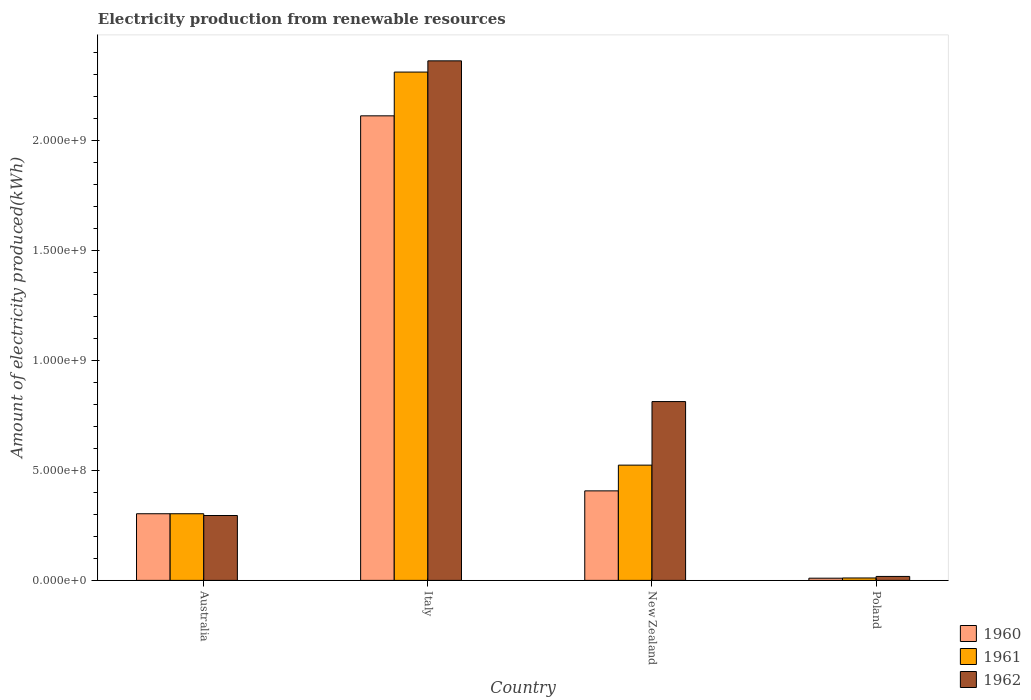How many different coloured bars are there?
Offer a very short reply. 3. What is the amount of electricity produced in 1962 in Australia?
Keep it short and to the point. 2.95e+08. Across all countries, what is the maximum amount of electricity produced in 1961?
Ensure brevity in your answer.  2.31e+09. Across all countries, what is the minimum amount of electricity produced in 1961?
Keep it short and to the point. 1.10e+07. In which country was the amount of electricity produced in 1960 minimum?
Ensure brevity in your answer.  Poland. What is the total amount of electricity produced in 1961 in the graph?
Give a very brief answer. 3.15e+09. What is the difference between the amount of electricity produced in 1962 in Italy and that in New Zealand?
Give a very brief answer. 1.55e+09. What is the difference between the amount of electricity produced in 1961 in Italy and the amount of electricity produced in 1960 in Australia?
Ensure brevity in your answer.  2.01e+09. What is the average amount of electricity produced in 1960 per country?
Provide a short and direct response. 7.08e+08. What is the difference between the amount of electricity produced of/in 1962 and amount of electricity produced of/in 1961 in New Zealand?
Ensure brevity in your answer.  2.89e+08. In how many countries, is the amount of electricity produced in 1961 greater than 500000000 kWh?
Offer a terse response. 2. What is the ratio of the amount of electricity produced in 1961 in Australia to that in Poland?
Provide a short and direct response. 27.55. Is the difference between the amount of electricity produced in 1962 in Australia and Poland greater than the difference between the amount of electricity produced in 1961 in Australia and Poland?
Offer a terse response. No. What is the difference between the highest and the second highest amount of electricity produced in 1961?
Make the answer very short. 1.79e+09. What is the difference between the highest and the lowest amount of electricity produced in 1960?
Your answer should be very brief. 2.10e+09. What does the 1st bar from the left in Poland represents?
Offer a very short reply. 1960. What does the 3rd bar from the right in New Zealand represents?
Keep it short and to the point. 1960. Is it the case that in every country, the sum of the amount of electricity produced in 1961 and amount of electricity produced in 1960 is greater than the amount of electricity produced in 1962?
Your response must be concise. Yes. Are all the bars in the graph horizontal?
Offer a terse response. No. What is the difference between two consecutive major ticks on the Y-axis?
Offer a terse response. 5.00e+08. Does the graph contain any zero values?
Give a very brief answer. No. Does the graph contain grids?
Provide a succinct answer. No. How many legend labels are there?
Provide a short and direct response. 3. What is the title of the graph?
Make the answer very short. Electricity production from renewable resources. What is the label or title of the Y-axis?
Keep it short and to the point. Amount of electricity produced(kWh). What is the Amount of electricity produced(kWh) of 1960 in Australia?
Your answer should be compact. 3.03e+08. What is the Amount of electricity produced(kWh) of 1961 in Australia?
Provide a succinct answer. 3.03e+08. What is the Amount of electricity produced(kWh) of 1962 in Australia?
Your response must be concise. 2.95e+08. What is the Amount of electricity produced(kWh) in 1960 in Italy?
Offer a very short reply. 2.11e+09. What is the Amount of electricity produced(kWh) in 1961 in Italy?
Your answer should be very brief. 2.31e+09. What is the Amount of electricity produced(kWh) in 1962 in Italy?
Keep it short and to the point. 2.36e+09. What is the Amount of electricity produced(kWh) of 1960 in New Zealand?
Offer a very short reply. 4.07e+08. What is the Amount of electricity produced(kWh) of 1961 in New Zealand?
Provide a succinct answer. 5.24e+08. What is the Amount of electricity produced(kWh) in 1962 in New Zealand?
Provide a succinct answer. 8.13e+08. What is the Amount of electricity produced(kWh) of 1961 in Poland?
Provide a succinct answer. 1.10e+07. What is the Amount of electricity produced(kWh) in 1962 in Poland?
Give a very brief answer. 1.80e+07. Across all countries, what is the maximum Amount of electricity produced(kWh) of 1960?
Give a very brief answer. 2.11e+09. Across all countries, what is the maximum Amount of electricity produced(kWh) in 1961?
Give a very brief answer. 2.31e+09. Across all countries, what is the maximum Amount of electricity produced(kWh) of 1962?
Make the answer very short. 2.36e+09. Across all countries, what is the minimum Amount of electricity produced(kWh) of 1961?
Keep it short and to the point. 1.10e+07. Across all countries, what is the minimum Amount of electricity produced(kWh) of 1962?
Make the answer very short. 1.80e+07. What is the total Amount of electricity produced(kWh) of 1960 in the graph?
Your answer should be very brief. 2.83e+09. What is the total Amount of electricity produced(kWh) of 1961 in the graph?
Ensure brevity in your answer.  3.15e+09. What is the total Amount of electricity produced(kWh) in 1962 in the graph?
Your answer should be very brief. 3.49e+09. What is the difference between the Amount of electricity produced(kWh) of 1960 in Australia and that in Italy?
Keep it short and to the point. -1.81e+09. What is the difference between the Amount of electricity produced(kWh) in 1961 in Australia and that in Italy?
Keep it short and to the point. -2.01e+09. What is the difference between the Amount of electricity produced(kWh) in 1962 in Australia and that in Italy?
Your answer should be compact. -2.07e+09. What is the difference between the Amount of electricity produced(kWh) of 1960 in Australia and that in New Zealand?
Offer a terse response. -1.04e+08. What is the difference between the Amount of electricity produced(kWh) in 1961 in Australia and that in New Zealand?
Provide a succinct answer. -2.21e+08. What is the difference between the Amount of electricity produced(kWh) of 1962 in Australia and that in New Zealand?
Provide a short and direct response. -5.18e+08. What is the difference between the Amount of electricity produced(kWh) in 1960 in Australia and that in Poland?
Provide a succinct answer. 2.93e+08. What is the difference between the Amount of electricity produced(kWh) of 1961 in Australia and that in Poland?
Keep it short and to the point. 2.92e+08. What is the difference between the Amount of electricity produced(kWh) in 1962 in Australia and that in Poland?
Give a very brief answer. 2.77e+08. What is the difference between the Amount of electricity produced(kWh) of 1960 in Italy and that in New Zealand?
Your answer should be compact. 1.70e+09. What is the difference between the Amount of electricity produced(kWh) of 1961 in Italy and that in New Zealand?
Keep it short and to the point. 1.79e+09. What is the difference between the Amount of electricity produced(kWh) of 1962 in Italy and that in New Zealand?
Provide a succinct answer. 1.55e+09. What is the difference between the Amount of electricity produced(kWh) of 1960 in Italy and that in Poland?
Provide a succinct answer. 2.10e+09. What is the difference between the Amount of electricity produced(kWh) in 1961 in Italy and that in Poland?
Ensure brevity in your answer.  2.30e+09. What is the difference between the Amount of electricity produced(kWh) in 1962 in Italy and that in Poland?
Keep it short and to the point. 2.34e+09. What is the difference between the Amount of electricity produced(kWh) of 1960 in New Zealand and that in Poland?
Make the answer very short. 3.97e+08. What is the difference between the Amount of electricity produced(kWh) in 1961 in New Zealand and that in Poland?
Ensure brevity in your answer.  5.13e+08. What is the difference between the Amount of electricity produced(kWh) in 1962 in New Zealand and that in Poland?
Give a very brief answer. 7.95e+08. What is the difference between the Amount of electricity produced(kWh) in 1960 in Australia and the Amount of electricity produced(kWh) in 1961 in Italy?
Your answer should be very brief. -2.01e+09. What is the difference between the Amount of electricity produced(kWh) in 1960 in Australia and the Amount of electricity produced(kWh) in 1962 in Italy?
Give a very brief answer. -2.06e+09. What is the difference between the Amount of electricity produced(kWh) of 1961 in Australia and the Amount of electricity produced(kWh) of 1962 in Italy?
Your answer should be compact. -2.06e+09. What is the difference between the Amount of electricity produced(kWh) in 1960 in Australia and the Amount of electricity produced(kWh) in 1961 in New Zealand?
Provide a short and direct response. -2.21e+08. What is the difference between the Amount of electricity produced(kWh) in 1960 in Australia and the Amount of electricity produced(kWh) in 1962 in New Zealand?
Your answer should be compact. -5.10e+08. What is the difference between the Amount of electricity produced(kWh) of 1961 in Australia and the Amount of electricity produced(kWh) of 1962 in New Zealand?
Ensure brevity in your answer.  -5.10e+08. What is the difference between the Amount of electricity produced(kWh) in 1960 in Australia and the Amount of electricity produced(kWh) in 1961 in Poland?
Offer a very short reply. 2.92e+08. What is the difference between the Amount of electricity produced(kWh) of 1960 in Australia and the Amount of electricity produced(kWh) of 1962 in Poland?
Your answer should be compact. 2.85e+08. What is the difference between the Amount of electricity produced(kWh) in 1961 in Australia and the Amount of electricity produced(kWh) in 1962 in Poland?
Offer a terse response. 2.85e+08. What is the difference between the Amount of electricity produced(kWh) in 1960 in Italy and the Amount of electricity produced(kWh) in 1961 in New Zealand?
Make the answer very short. 1.59e+09. What is the difference between the Amount of electricity produced(kWh) in 1960 in Italy and the Amount of electricity produced(kWh) in 1962 in New Zealand?
Offer a very short reply. 1.30e+09. What is the difference between the Amount of electricity produced(kWh) of 1961 in Italy and the Amount of electricity produced(kWh) of 1962 in New Zealand?
Provide a short and direct response. 1.50e+09. What is the difference between the Amount of electricity produced(kWh) in 1960 in Italy and the Amount of electricity produced(kWh) in 1961 in Poland?
Give a very brief answer. 2.10e+09. What is the difference between the Amount of electricity produced(kWh) of 1960 in Italy and the Amount of electricity produced(kWh) of 1962 in Poland?
Your response must be concise. 2.09e+09. What is the difference between the Amount of electricity produced(kWh) of 1961 in Italy and the Amount of electricity produced(kWh) of 1962 in Poland?
Give a very brief answer. 2.29e+09. What is the difference between the Amount of electricity produced(kWh) in 1960 in New Zealand and the Amount of electricity produced(kWh) in 1961 in Poland?
Your answer should be compact. 3.96e+08. What is the difference between the Amount of electricity produced(kWh) in 1960 in New Zealand and the Amount of electricity produced(kWh) in 1962 in Poland?
Make the answer very short. 3.89e+08. What is the difference between the Amount of electricity produced(kWh) of 1961 in New Zealand and the Amount of electricity produced(kWh) of 1962 in Poland?
Your answer should be compact. 5.06e+08. What is the average Amount of electricity produced(kWh) in 1960 per country?
Provide a succinct answer. 7.08e+08. What is the average Amount of electricity produced(kWh) of 1961 per country?
Make the answer very short. 7.87e+08. What is the average Amount of electricity produced(kWh) in 1962 per country?
Make the answer very short. 8.72e+08. What is the difference between the Amount of electricity produced(kWh) of 1960 and Amount of electricity produced(kWh) of 1961 in Australia?
Offer a terse response. 0. What is the difference between the Amount of electricity produced(kWh) of 1960 and Amount of electricity produced(kWh) of 1962 in Australia?
Your answer should be very brief. 8.00e+06. What is the difference between the Amount of electricity produced(kWh) of 1960 and Amount of electricity produced(kWh) of 1961 in Italy?
Offer a very short reply. -1.99e+08. What is the difference between the Amount of electricity produced(kWh) in 1960 and Amount of electricity produced(kWh) in 1962 in Italy?
Provide a succinct answer. -2.50e+08. What is the difference between the Amount of electricity produced(kWh) in 1961 and Amount of electricity produced(kWh) in 1962 in Italy?
Your response must be concise. -5.10e+07. What is the difference between the Amount of electricity produced(kWh) in 1960 and Amount of electricity produced(kWh) in 1961 in New Zealand?
Give a very brief answer. -1.17e+08. What is the difference between the Amount of electricity produced(kWh) in 1960 and Amount of electricity produced(kWh) in 1962 in New Zealand?
Your response must be concise. -4.06e+08. What is the difference between the Amount of electricity produced(kWh) of 1961 and Amount of electricity produced(kWh) of 1962 in New Zealand?
Give a very brief answer. -2.89e+08. What is the difference between the Amount of electricity produced(kWh) in 1960 and Amount of electricity produced(kWh) in 1961 in Poland?
Ensure brevity in your answer.  -1.00e+06. What is the difference between the Amount of electricity produced(kWh) of 1960 and Amount of electricity produced(kWh) of 1962 in Poland?
Your answer should be compact. -8.00e+06. What is the difference between the Amount of electricity produced(kWh) in 1961 and Amount of electricity produced(kWh) in 1962 in Poland?
Make the answer very short. -7.00e+06. What is the ratio of the Amount of electricity produced(kWh) in 1960 in Australia to that in Italy?
Make the answer very short. 0.14. What is the ratio of the Amount of electricity produced(kWh) in 1961 in Australia to that in Italy?
Your answer should be very brief. 0.13. What is the ratio of the Amount of electricity produced(kWh) in 1962 in Australia to that in Italy?
Your answer should be compact. 0.12. What is the ratio of the Amount of electricity produced(kWh) in 1960 in Australia to that in New Zealand?
Keep it short and to the point. 0.74. What is the ratio of the Amount of electricity produced(kWh) in 1961 in Australia to that in New Zealand?
Make the answer very short. 0.58. What is the ratio of the Amount of electricity produced(kWh) in 1962 in Australia to that in New Zealand?
Your response must be concise. 0.36. What is the ratio of the Amount of electricity produced(kWh) of 1960 in Australia to that in Poland?
Ensure brevity in your answer.  30.3. What is the ratio of the Amount of electricity produced(kWh) of 1961 in Australia to that in Poland?
Make the answer very short. 27.55. What is the ratio of the Amount of electricity produced(kWh) of 1962 in Australia to that in Poland?
Your answer should be compact. 16.39. What is the ratio of the Amount of electricity produced(kWh) of 1960 in Italy to that in New Zealand?
Offer a very short reply. 5.19. What is the ratio of the Amount of electricity produced(kWh) in 1961 in Italy to that in New Zealand?
Offer a very short reply. 4.41. What is the ratio of the Amount of electricity produced(kWh) in 1962 in Italy to that in New Zealand?
Offer a very short reply. 2.91. What is the ratio of the Amount of electricity produced(kWh) in 1960 in Italy to that in Poland?
Your answer should be very brief. 211.2. What is the ratio of the Amount of electricity produced(kWh) of 1961 in Italy to that in Poland?
Give a very brief answer. 210.09. What is the ratio of the Amount of electricity produced(kWh) in 1962 in Italy to that in Poland?
Ensure brevity in your answer.  131.22. What is the ratio of the Amount of electricity produced(kWh) of 1960 in New Zealand to that in Poland?
Your answer should be very brief. 40.7. What is the ratio of the Amount of electricity produced(kWh) in 1961 in New Zealand to that in Poland?
Provide a succinct answer. 47.64. What is the ratio of the Amount of electricity produced(kWh) in 1962 in New Zealand to that in Poland?
Provide a short and direct response. 45.17. What is the difference between the highest and the second highest Amount of electricity produced(kWh) of 1960?
Offer a very short reply. 1.70e+09. What is the difference between the highest and the second highest Amount of electricity produced(kWh) in 1961?
Ensure brevity in your answer.  1.79e+09. What is the difference between the highest and the second highest Amount of electricity produced(kWh) in 1962?
Offer a very short reply. 1.55e+09. What is the difference between the highest and the lowest Amount of electricity produced(kWh) in 1960?
Offer a very short reply. 2.10e+09. What is the difference between the highest and the lowest Amount of electricity produced(kWh) in 1961?
Offer a very short reply. 2.30e+09. What is the difference between the highest and the lowest Amount of electricity produced(kWh) in 1962?
Make the answer very short. 2.34e+09. 